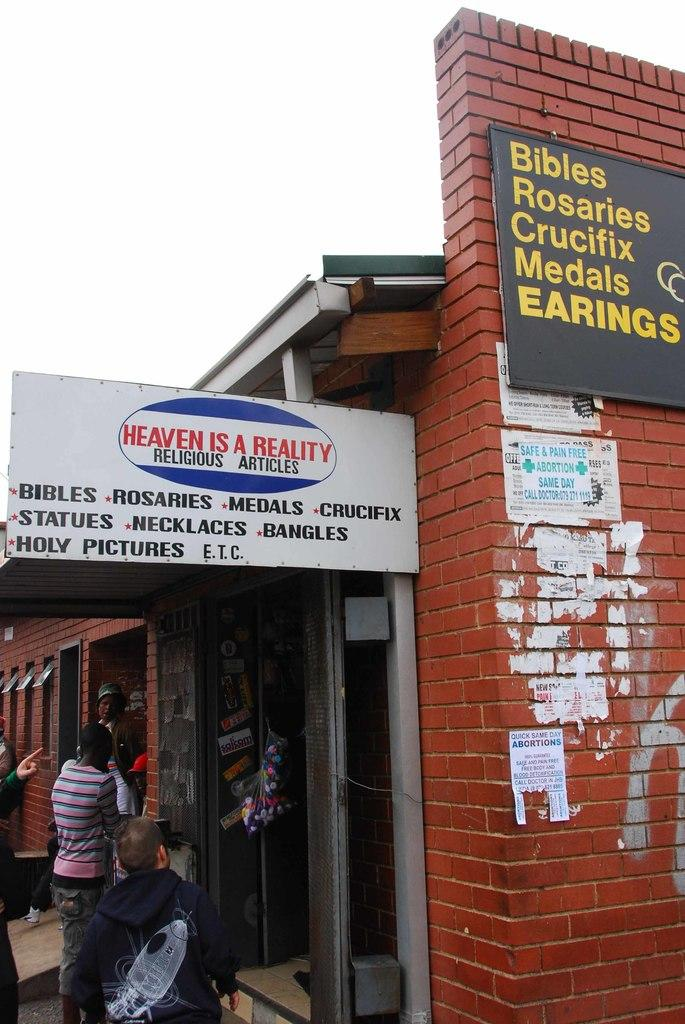What can be seen in the image? There are people standing in front of shops. What is written on the top of the shops? There are name boards on top of the shops. How many shops can be seen in the image? The number of shops is not specified, but there are at least two shops visible, as there are people standing in front of them. What type of humor can be seen in the image? There is no humor present in the image; it features people standing in front of shops with name boards on top of them. Can you tell me how many people are in the group in the image? The term "group" is not mentioned in the provided facts, and the number of people is not specified. However, there are at least two people visible, as they are standing in front of the shops. 